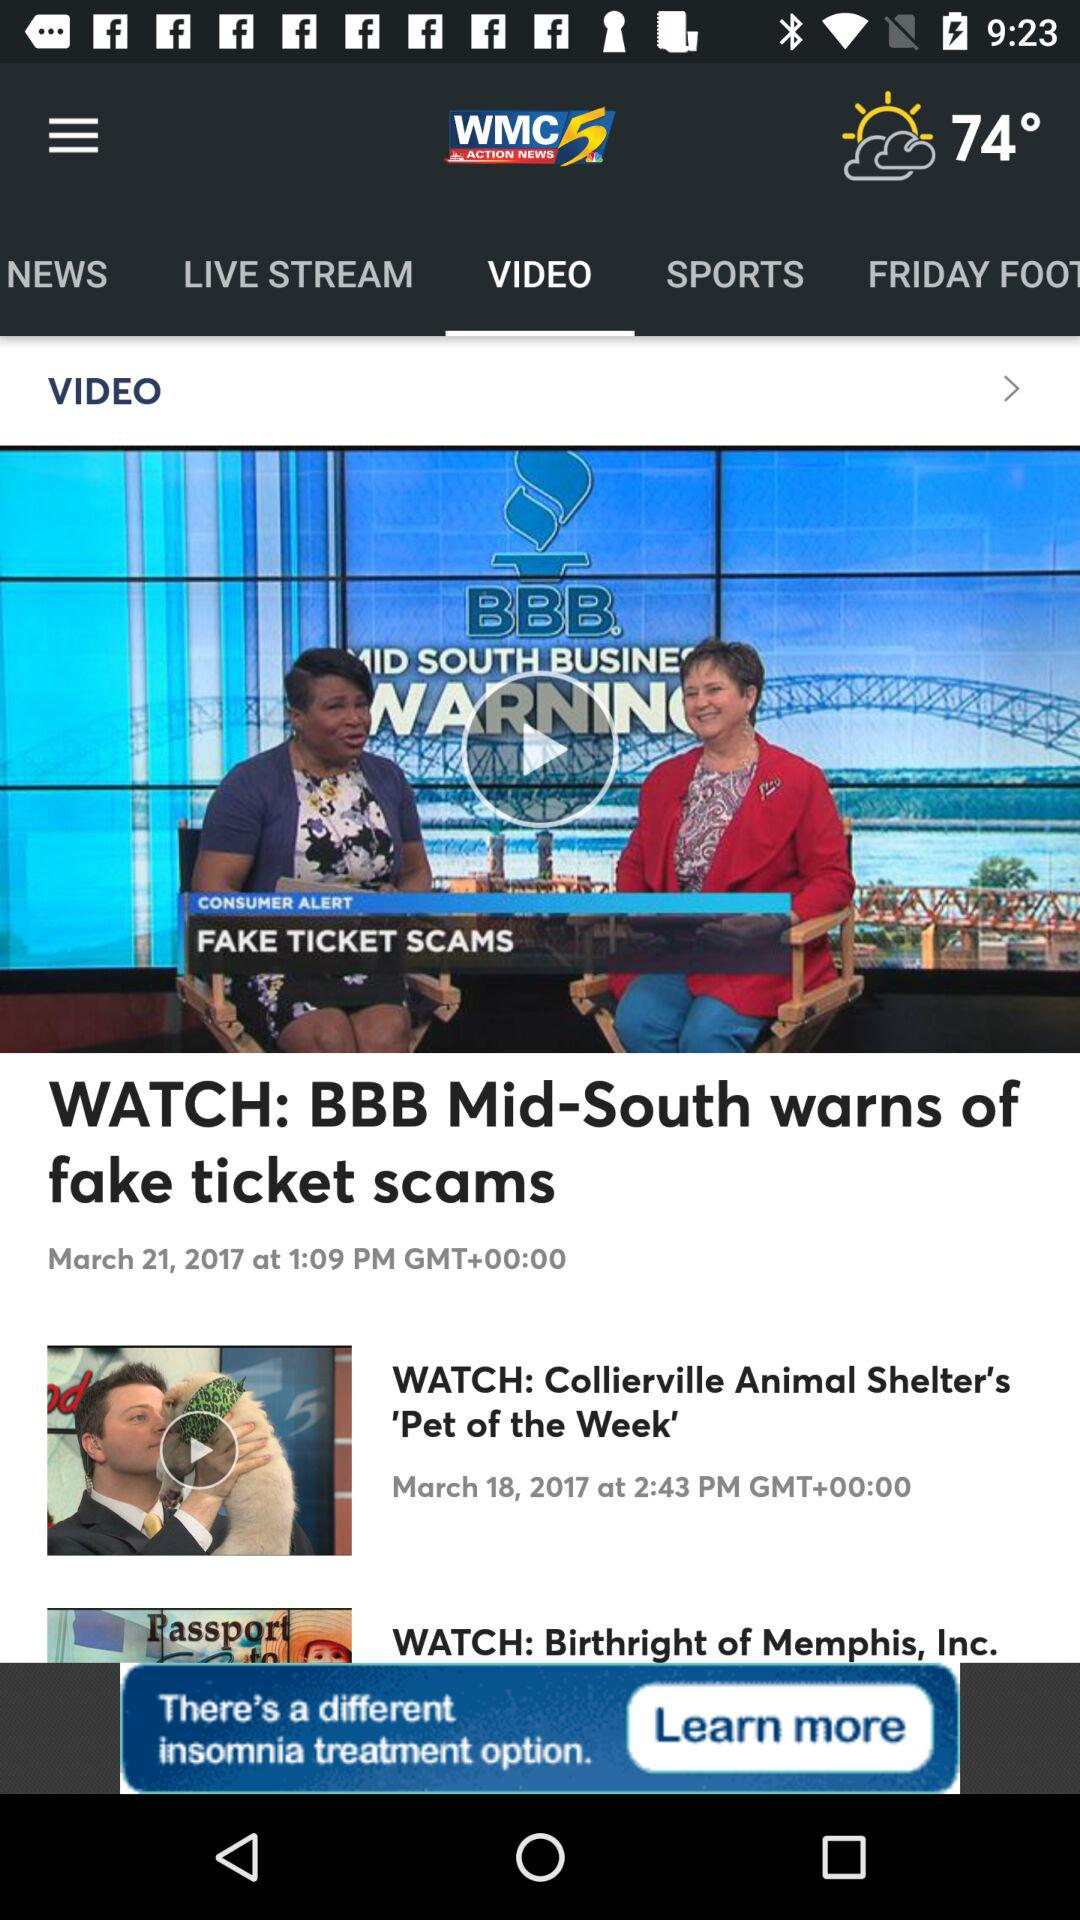Which show was broadcast on March 18, 2017? The show was "Collierville Animal Shelter's 'Pet of the Week'". 